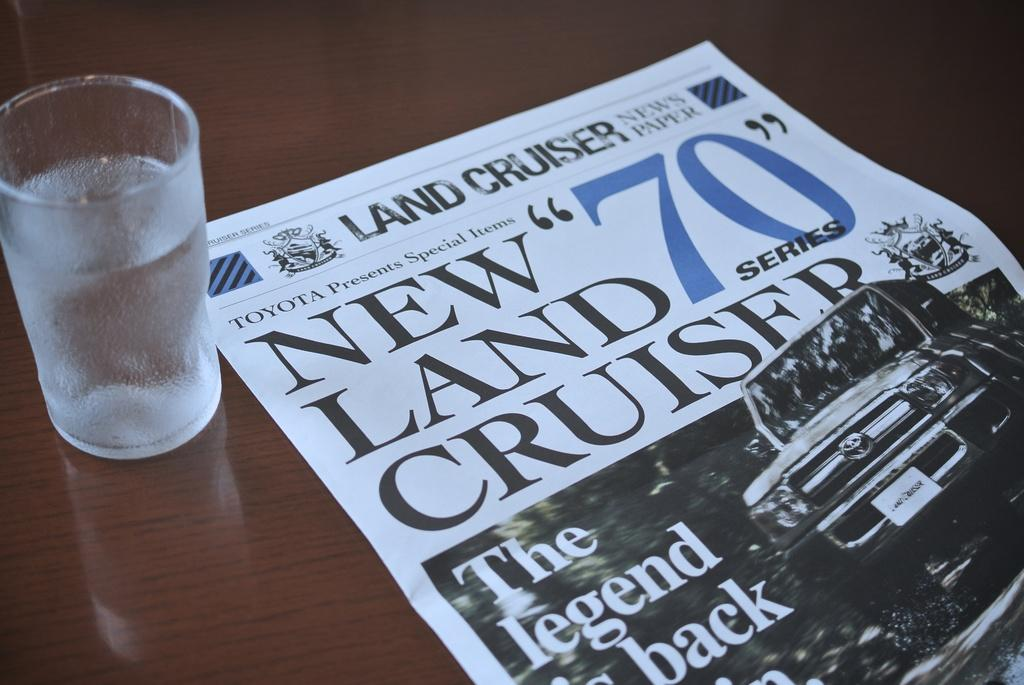<image>
Create a compact narrative representing the image presented. A glass of water sits next to a paper advertisement for the Toyota Land Cruiser. 